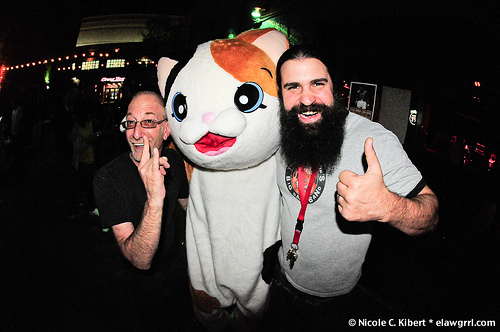<image>
Is there a toy above the man? Yes. The toy is positioned above the man in the vertical space, higher up in the scene. 